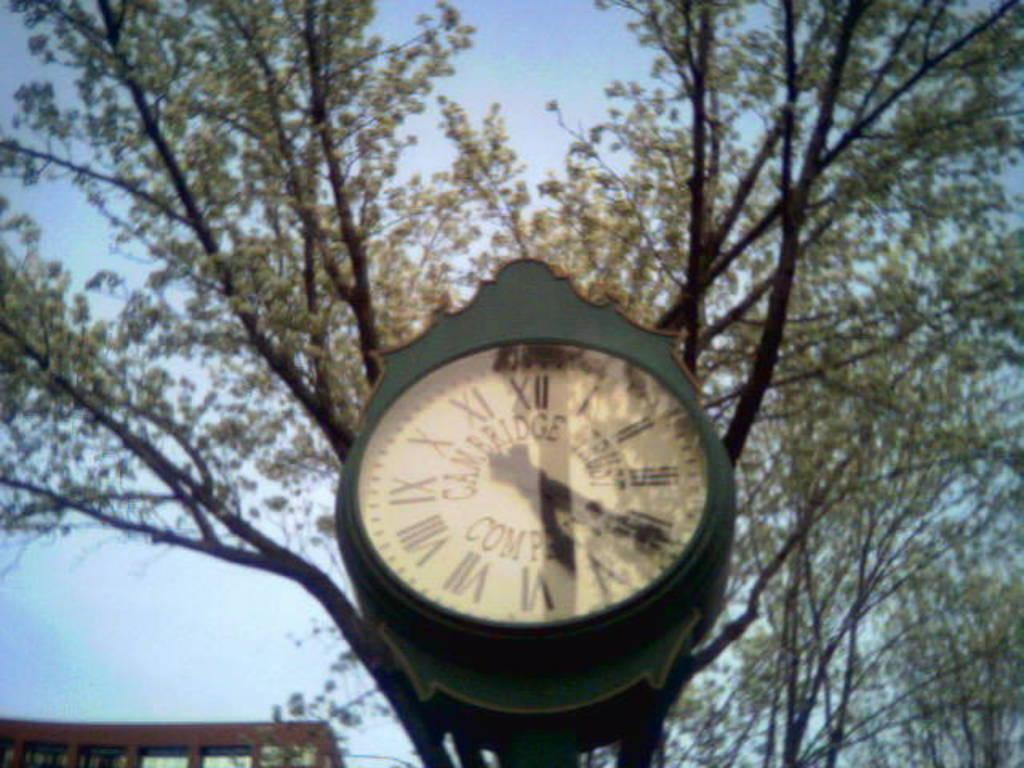Provide a one-sentence caption for the provided image. Cambridge trust company clock that is green and roman numerals. 